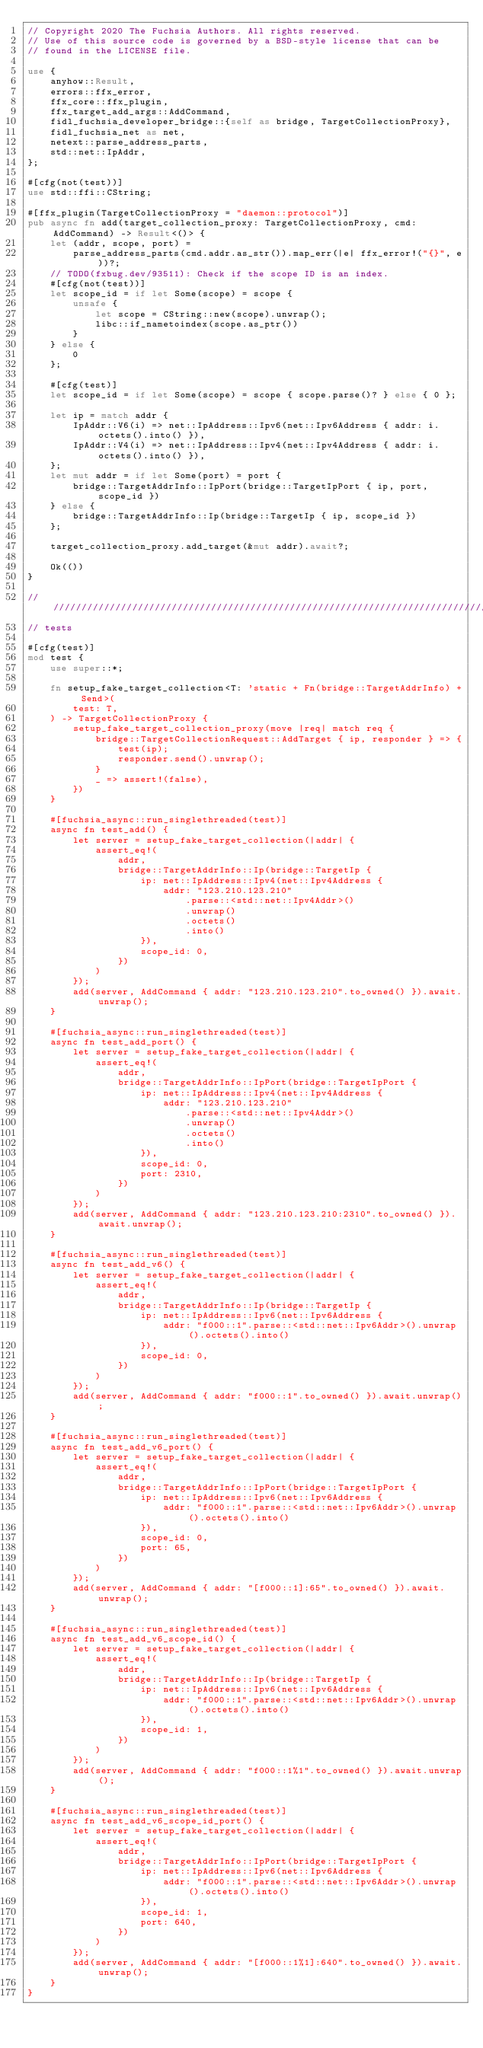Convert code to text. <code><loc_0><loc_0><loc_500><loc_500><_Rust_>// Copyright 2020 The Fuchsia Authors. All rights reserved.
// Use of this source code is governed by a BSD-style license that can be
// found in the LICENSE file.

use {
    anyhow::Result,
    errors::ffx_error,
    ffx_core::ffx_plugin,
    ffx_target_add_args::AddCommand,
    fidl_fuchsia_developer_bridge::{self as bridge, TargetCollectionProxy},
    fidl_fuchsia_net as net,
    netext::parse_address_parts,
    std::net::IpAddr,
};

#[cfg(not(test))]
use std::ffi::CString;

#[ffx_plugin(TargetCollectionProxy = "daemon::protocol")]
pub async fn add(target_collection_proxy: TargetCollectionProxy, cmd: AddCommand) -> Result<()> {
    let (addr, scope, port) =
        parse_address_parts(cmd.addr.as_str()).map_err(|e| ffx_error!("{}", e))?;
    // TODO(fxbug.dev/93511): Check if the scope ID is an index.
    #[cfg(not(test))]
    let scope_id = if let Some(scope) = scope {
        unsafe {
            let scope = CString::new(scope).unwrap();
            libc::if_nametoindex(scope.as_ptr())
        }
    } else {
        0
    };

    #[cfg(test)]
    let scope_id = if let Some(scope) = scope { scope.parse()? } else { 0 };

    let ip = match addr {
        IpAddr::V6(i) => net::IpAddress::Ipv6(net::Ipv6Address { addr: i.octets().into() }),
        IpAddr::V4(i) => net::IpAddress::Ipv4(net::Ipv4Address { addr: i.octets().into() }),
    };
    let mut addr = if let Some(port) = port {
        bridge::TargetAddrInfo::IpPort(bridge::TargetIpPort { ip, port, scope_id })
    } else {
        bridge::TargetAddrInfo::Ip(bridge::TargetIp { ip, scope_id })
    };

    target_collection_proxy.add_target(&mut addr).await?;

    Ok(())
}

////////////////////////////////////////////////////////////////////////////////
// tests

#[cfg(test)]
mod test {
    use super::*;

    fn setup_fake_target_collection<T: 'static + Fn(bridge::TargetAddrInfo) + Send>(
        test: T,
    ) -> TargetCollectionProxy {
        setup_fake_target_collection_proxy(move |req| match req {
            bridge::TargetCollectionRequest::AddTarget { ip, responder } => {
                test(ip);
                responder.send().unwrap();
            }
            _ => assert!(false),
        })
    }

    #[fuchsia_async::run_singlethreaded(test)]
    async fn test_add() {
        let server = setup_fake_target_collection(|addr| {
            assert_eq!(
                addr,
                bridge::TargetAddrInfo::Ip(bridge::TargetIp {
                    ip: net::IpAddress::Ipv4(net::Ipv4Address {
                        addr: "123.210.123.210"
                            .parse::<std::net::Ipv4Addr>()
                            .unwrap()
                            .octets()
                            .into()
                    }),
                    scope_id: 0,
                })
            )
        });
        add(server, AddCommand { addr: "123.210.123.210".to_owned() }).await.unwrap();
    }

    #[fuchsia_async::run_singlethreaded(test)]
    async fn test_add_port() {
        let server = setup_fake_target_collection(|addr| {
            assert_eq!(
                addr,
                bridge::TargetAddrInfo::IpPort(bridge::TargetIpPort {
                    ip: net::IpAddress::Ipv4(net::Ipv4Address {
                        addr: "123.210.123.210"
                            .parse::<std::net::Ipv4Addr>()
                            .unwrap()
                            .octets()
                            .into()
                    }),
                    scope_id: 0,
                    port: 2310,
                })
            )
        });
        add(server, AddCommand { addr: "123.210.123.210:2310".to_owned() }).await.unwrap();
    }

    #[fuchsia_async::run_singlethreaded(test)]
    async fn test_add_v6() {
        let server = setup_fake_target_collection(|addr| {
            assert_eq!(
                addr,
                bridge::TargetAddrInfo::Ip(bridge::TargetIp {
                    ip: net::IpAddress::Ipv6(net::Ipv6Address {
                        addr: "f000::1".parse::<std::net::Ipv6Addr>().unwrap().octets().into()
                    }),
                    scope_id: 0,
                })
            )
        });
        add(server, AddCommand { addr: "f000::1".to_owned() }).await.unwrap();
    }

    #[fuchsia_async::run_singlethreaded(test)]
    async fn test_add_v6_port() {
        let server = setup_fake_target_collection(|addr| {
            assert_eq!(
                addr,
                bridge::TargetAddrInfo::IpPort(bridge::TargetIpPort {
                    ip: net::IpAddress::Ipv6(net::Ipv6Address {
                        addr: "f000::1".parse::<std::net::Ipv6Addr>().unwrap().octets().into()
                    }),
                    scope_id: 0,
                    port: 65,
                })
            )
        });
        add(server, AddCommand { addr: "[f000::1]:65".to_owned() }).await.unwrap();
    }

    #[fuchsia_async::run_singlethreaded(test)]
    async fn test_add_v6_scope_id() {
        let server = setup_fake_target_collection(|addr| {
            assert_eq!(
                addr,
                bridge::TargetAddrInfo::Ip(bridge::TargetIp {
                    ip: net::IpAddress::Ipv6(net::Ipv6Address {
                        addr: "f000::1".parse::<std::net::Ipv6Addr>().unwrap().octets().into()
                    }),
                    scope_id: 1,
                })
            )
        });
        add(server, AddCommand { addr: "f000::1%1".to_owned() }).await.unwrap();
    }

    #[fuchsia_async::run_singlethreaded(test)]
    async fn test_add_v6_scope_id_port() {
        let server = setup_fake_target_collection(|addr| {
            assert_eq!(
                addr,
                bridge::TargetAddrInfo::IpPort(bridge::TargetIpPort {
                    ip: net::IpAddress::Ipv6(net::Ipv6Address {
                        addr: "f000::1".parse::<std::net::Ipv6Addr>().unwrap().octets().into()
                    }),
                    scope_id: 1,
                    port: 640,
                })
            )
        });
        add(server, AddCommand { addr: "[f000::1%1]:640".to_owned() }).await.unwrap();
    }
}
</code> 